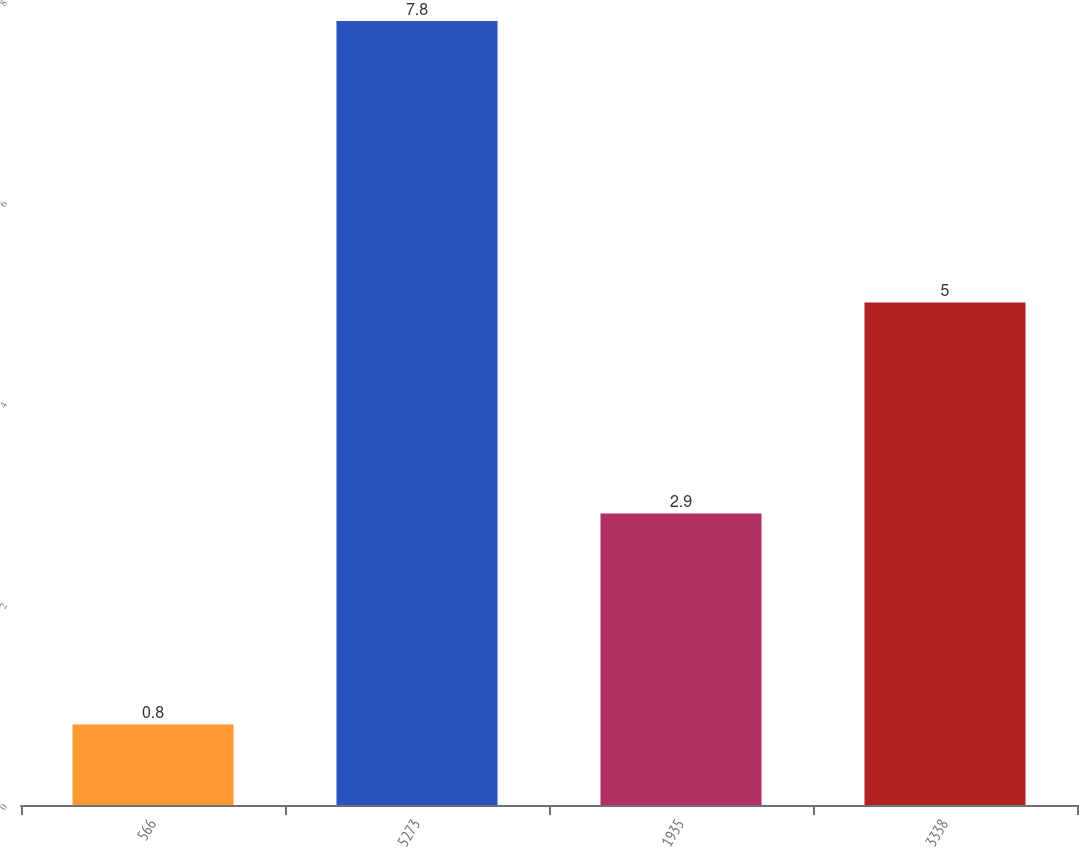Convert chart to OTSL. <chart><loc_0><loc_0><loc_500><loc_500><bar_chart><fcel>566<fcel>5273<fcel>1935<fcel>3338<nl><fcel>0.8<fcel>7.8<fcel>2.9<fcel>5<nl></chart> 